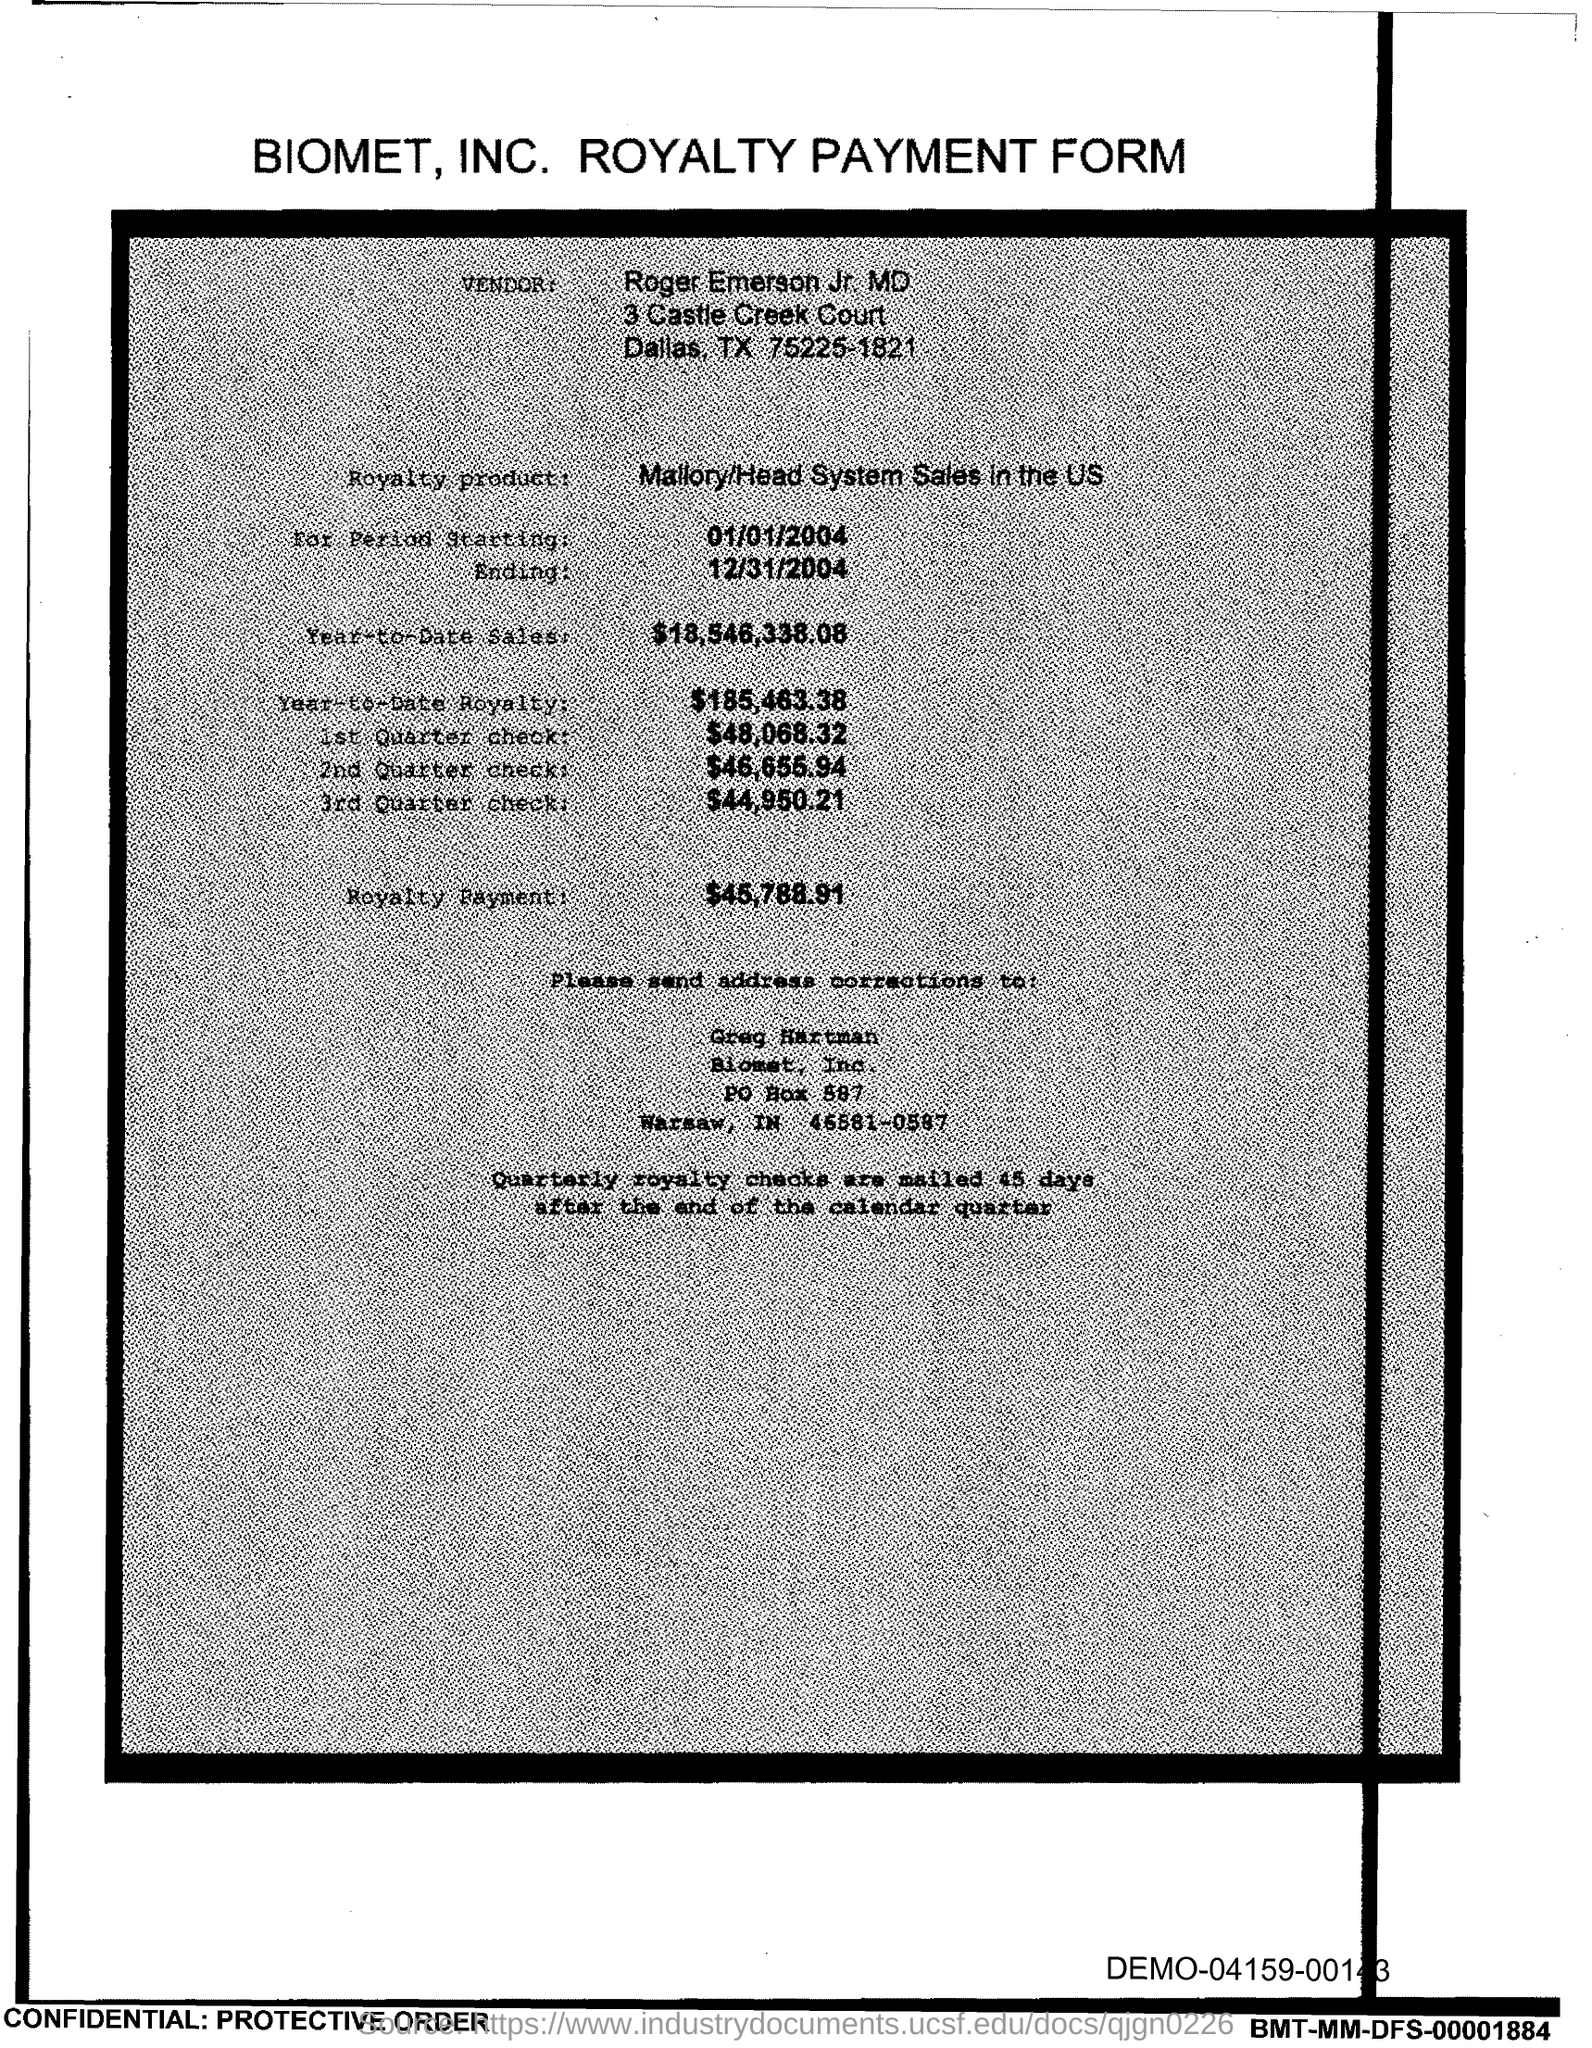What is the form about?
Your answer should be compact. Biomet, Inc. Royalty Payment Form. Who is the vendor?
Offer a very short reply. Roger Emerson Jr  MD. What is the Royalty product mentioned?
Provide a short and direct response. Mallory/Head System Sales in the US. 